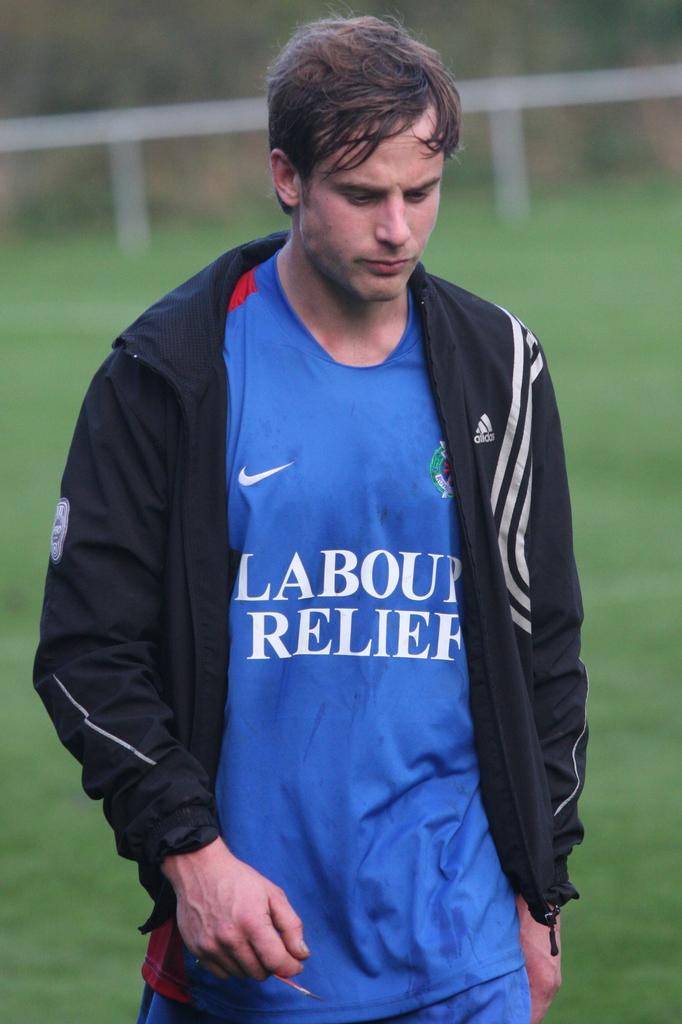Provide a one-sentence caption for the provided image. A white gentleman wearing a sporty adidas jacket over a blue shirt. 